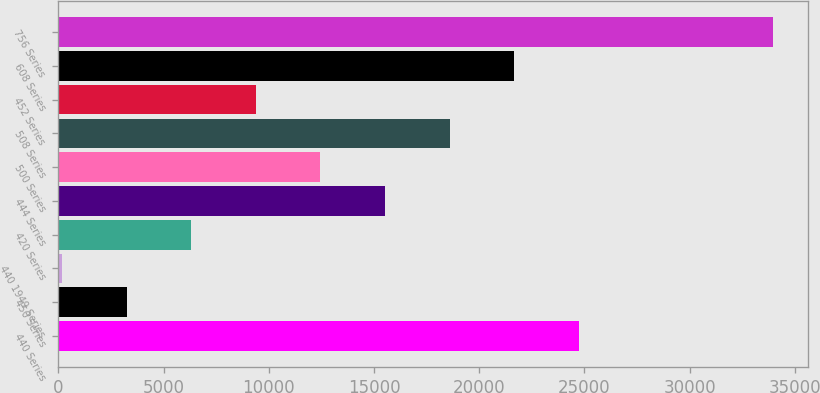<chart> <loc_0><loc_0><loc_500><loc_500><bar_chart><fcel>440 Series<fcel>450 Series<fcel>440 1949 Series<fcel>420 Series<fcel>444 Series<fcel>500 Series<fcel>508 Series<fcel>452 Series<fcel>608 Series<fcel>756 Series<nl><fcel>24739.6<fcel>3237.7<fcel>166<fcel>6309.4<fcel>15524.5<fcel>12452.8<fcel>18596.2<fcel>9381.1<fcel>21667.9<fcel>33954.7<nl></chart> 